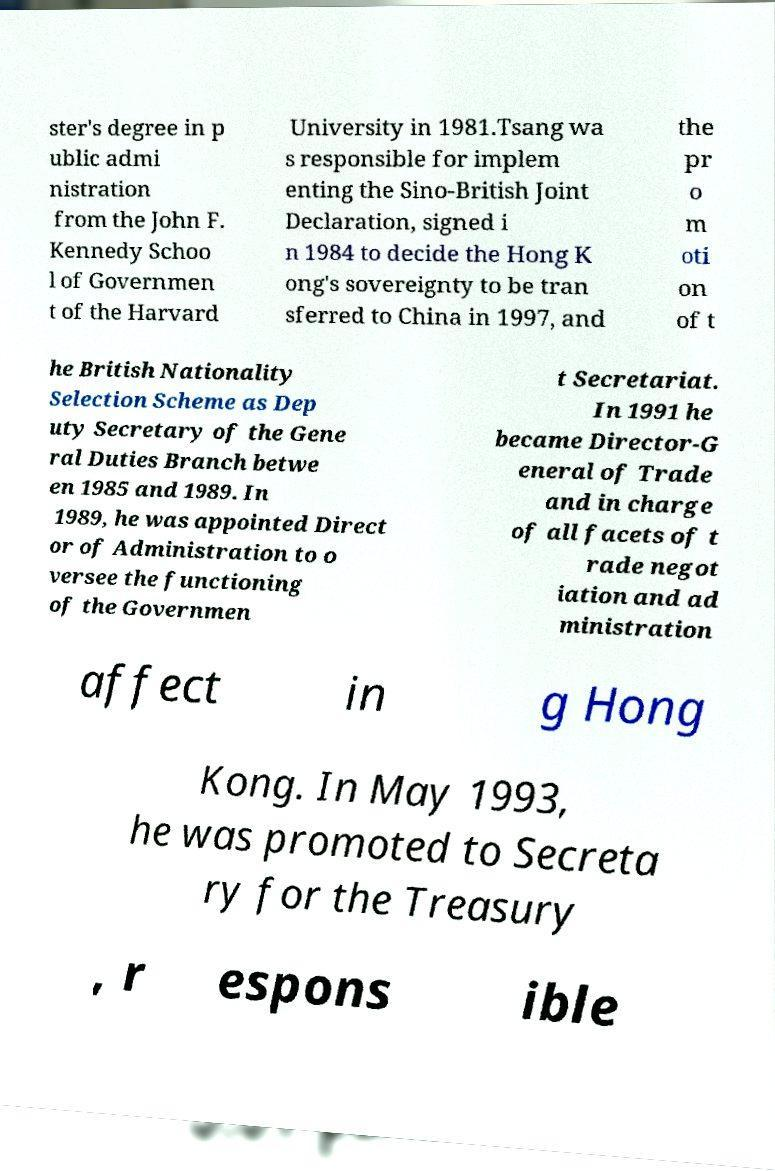For documentation purposes, I need the text within this image transcribed. Could you provide that? ster's degree in p ublic admi nistration from the John F. Kennedy Schoo l of Governmen t of the Harvard University in 1981.Tsang wa s responsible for implem enting the Sino-British Joint Declaration, signed i n 1984 to decide the Hong K ong's sovereignty to be tran sferred to China in 1997, and the pr o m oti on of t he British Nationality Selection Scheme as Dep uty Secretary of the Gene ral Duties Branch betwe en 1985 and 1989. In 1989, he was appointed Direct or of Administration to o versee the functioning of the Governmen t Secretariat. In 1991 he became Director-G eneral of Trade and in charge of all facets of t rade negot iation and ad ministration affect in g Hong Kong. In May 1993, he was promoted to Secreta ry for the Treasury , r espons ible 